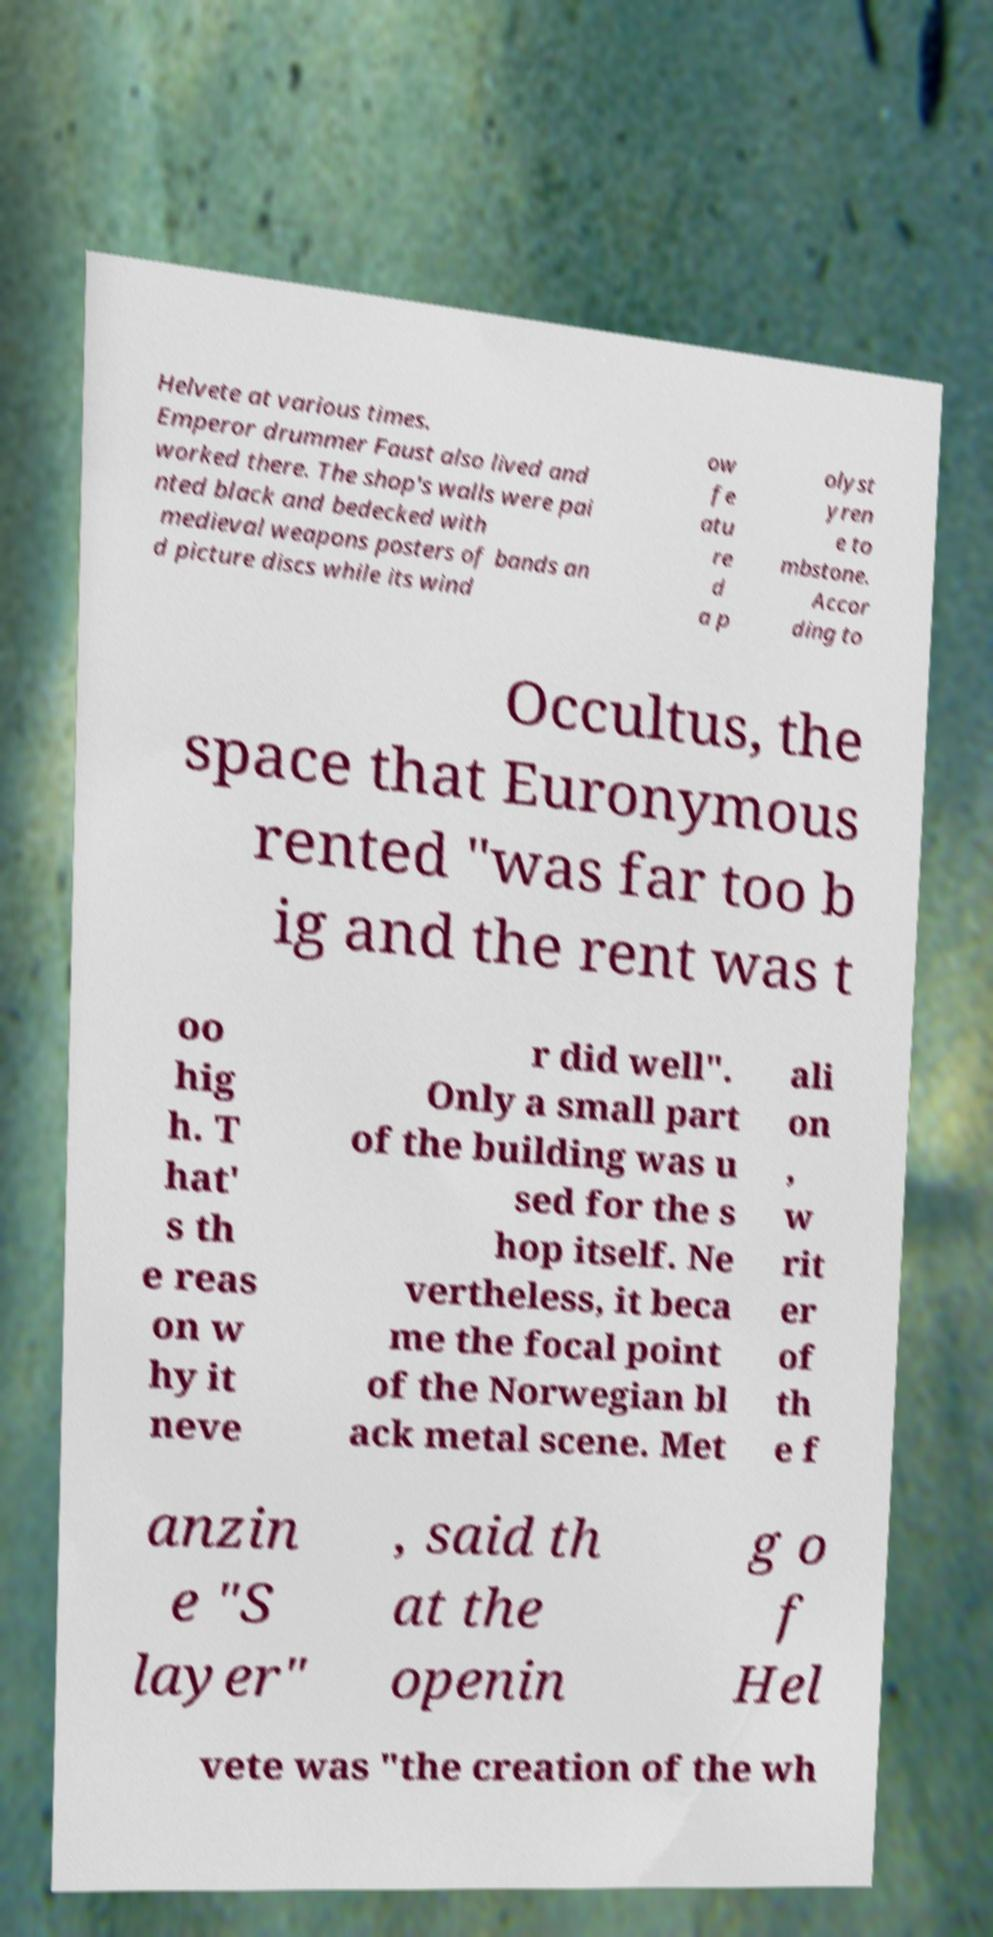For documentation purposes, I need the text within this image transcribed. Could you provide that? Helvete at various times. Emperor drummer Faust also lived and worked there. The shop's walls were pai nted black and bedecked with medieval weapons posters of bands an d picture discs while its wind ow fe atu re d a p olyst yren e to mbstone. Accor ding to Occultus, the space that Euronymous rented "was far too b ig and the rent was t oo hig h. T hat' s th e reas on w hy it neve r did well". Only a small part of the building was u sed for the s hop itself. Ne vertheless, it beca me the focal point of the Norwegian bl ack metal scene. Met ali on , w rit er of th e f anzin e "S layer" , said th at the openin g o f Hel vete was "the creation of the wh 